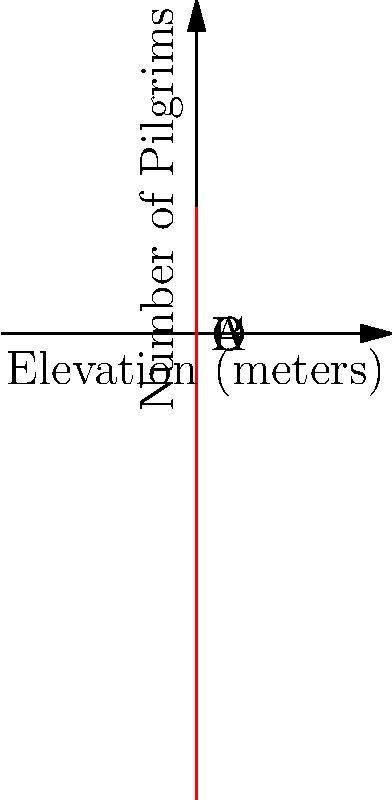The graph above represents the relationship between the elevation of religious sites and the number of pilgrims visiting them, modeled by a quartic polynomial. Points A, B, C, and D represent specific religious sites at different elevations. Which site is likely to attract the most pilgrims, and what cultural factors might contribute to this peak in visitation? To answer this question, we need to analyze the graph and consider cultural factors:

1. Observe the graph: It's a quartic polynomial with one global maximum.

2. Identify the highest point: The peak of the curve corresponds to the site that attracts the most pilgrims.

3. Locate the peak: It appears to be closest to point B at 1000 meters elevation.

4. Cultural factors to consider:
   a) Accessibility: 1000 meters is high enough to be considered sacred but still relatively accessible.
   b) Religious significance: Moderate elevations often have religious importance in many cultures.
   c) Climate: This elevation might offer a comfortable climate for pilgrimage.
   d) Historical context: Important religious events or figures might be associated with this elevation.

5. Compare to other points:
   A (500m): Lower elevation, possibly less spiritually significant.
   C (2000m) and D (3000m): Higher elevations might be too challenging for many pilgrims.

6. Sociocultural perspective: The peak at B suggests a balance between spiritual significance and practical accessibility, which aligns with many religious practices.
Answer: Site B (1000m elevation) attracts the most pilgrims, likely due to its balance of spiritual significance and accessibility. 